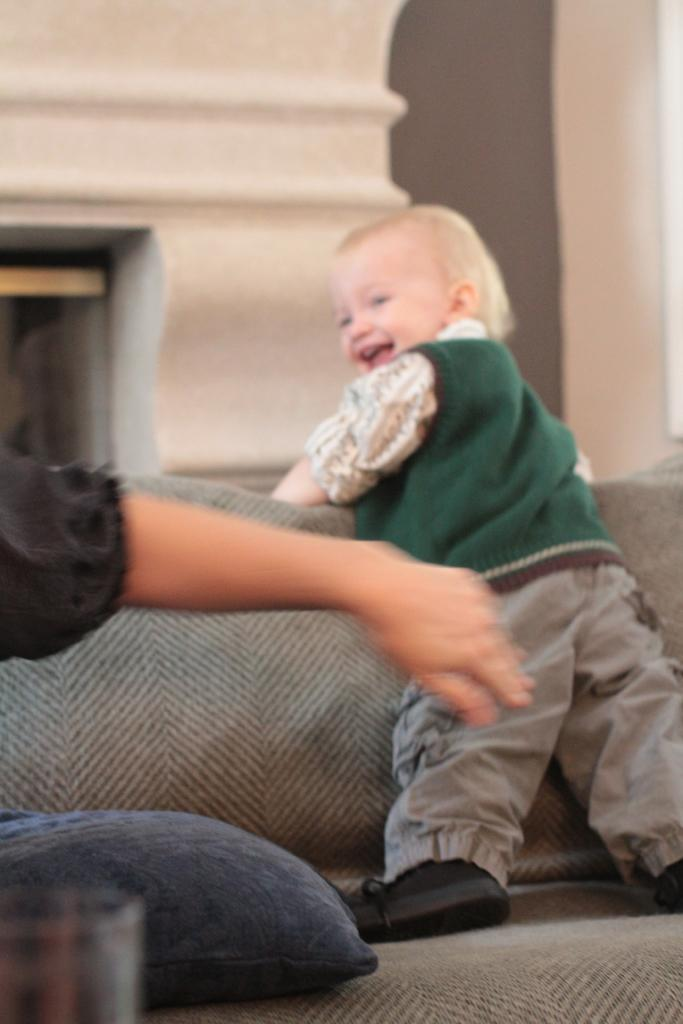What is the kid doing on the sofa in the image? The kid is standing on the sofa in the image. What is the kid's facial expression? The kid is smiling in the image. Whose hand is visible on the left side of the image? There is a person's hand visible on the left side of the image. What is on the sofa besides the kid? There is a glass and a pillow on the sofa. What can be seen in the background of the image? There is a wall and an object in the background of the image. What type of cloth is being used to cover the cattle in the image? There are no cattle or cloth present in the image. How many fifths are visible in the image? The term "fifth" does not apply to any elements in the image, as it is not a characteristic of the objects or subjects present. 